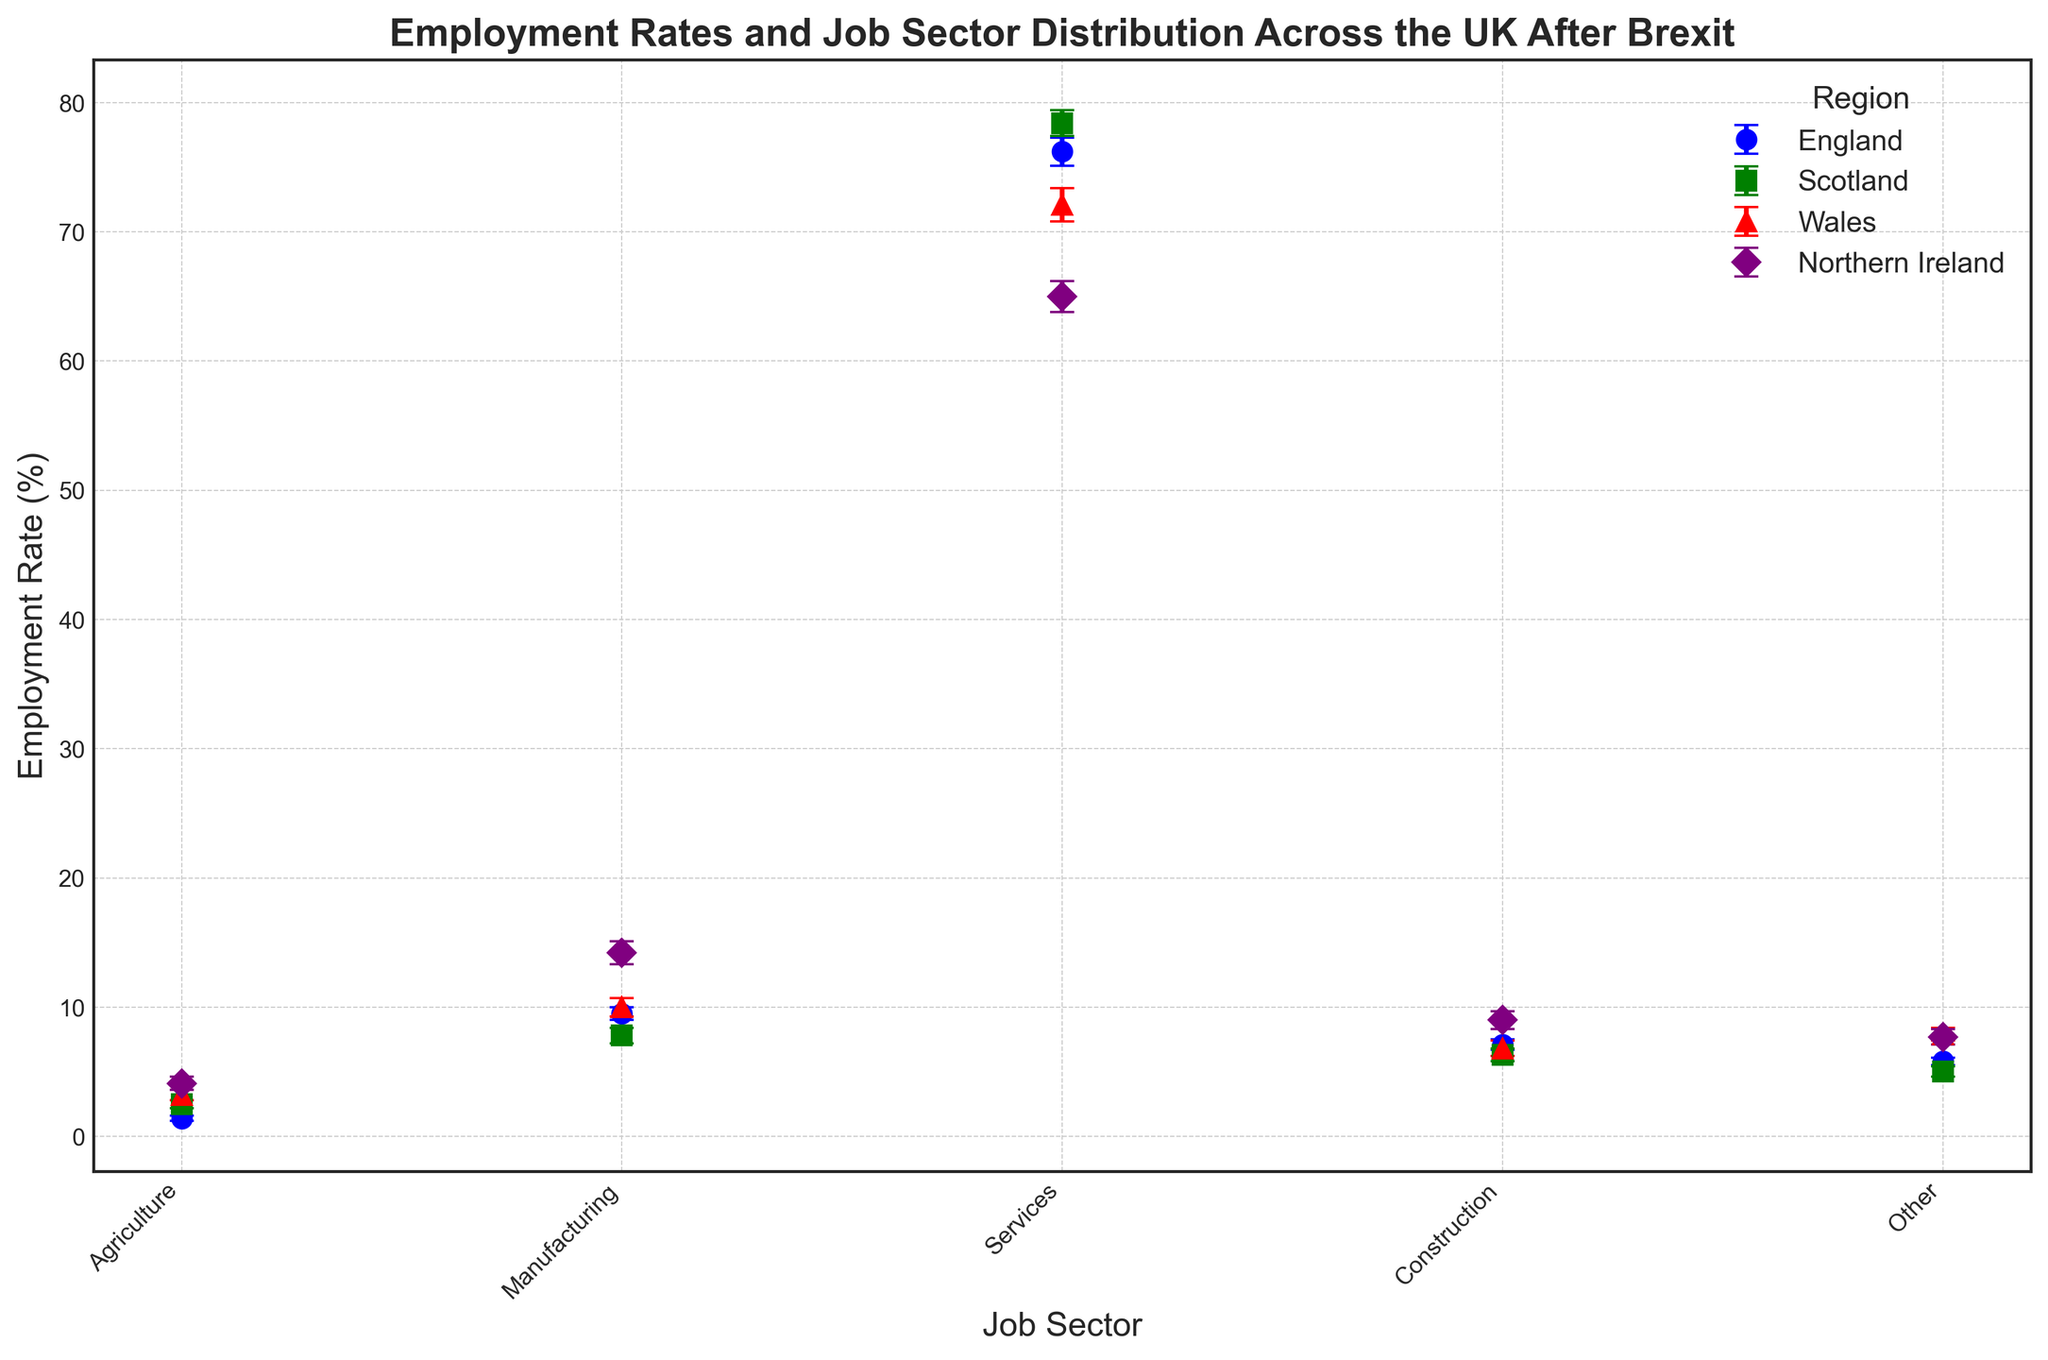How does the employment rate in agriculture differ between England and Wales? Find the employment rate for agriculture in both regions from the chart. England has an employment rate of 1.4% in agriculture, while Wales has an employment rate of 3.2%. Subtract the employment rate of England from that of Wales to find the difference. 3.2% - 1.4% = 1.8%
Answer: 1.8% Which region has the highest employment rate in services, and what is that rate? Identify the employment rate in services for each region from the chart. Scotland has the highest employment rate in services at 78.4%.
Answer: Scotland, 78.4% Compare the employment rates in manufacturing between Scotland and Northern Ireland. Which region has a higher rate, and by how much? Identify the manufacturing employment rates for Scotland and Northern Ireland from the chart. Scotland has a rate of 7.8%, while Northern Ireland has a rate of 14.2%. Subtract Scotland's rate from Northern Ireland's rate. 14.2% - 7.8% = 6.4%
Answer: Northern Ireland, 6.4% What is the average employment rate in construction across all regions, and which region has the nearest employment rate to this average? Add the employment rates in construction for all regions: 7.1% (England) + 6.3% (Scotland) + 6.8% (Wales) + 9.0% (Northern Ireland). Divide the sum by the number of regions (4). (7.1 + 6.3 + 6.8 + 9.0) / 4 = 29.2 / 4 = 7.3%. Wales has the nearest employment rate at 6.8%.
Answer: 7.3%, Wales Which region has the smallest standard error in the manufacturing sector, and what is that value? Identify the standard errors for the manufacturing sector in each region from the chart. England has the smallest standard error at 0.5%.
Answer: England, 0.5% How do the employment rates in the 'Other' sector for Wales and Northern Ireland compare visually on the chart? Look at the markers representing the 'Other' sector for both regions. Wales has a higher employment rate in the 'Other' sector (7.9%) compared to Northern Ireland (7.7%) as seen by the respective marker positions on the y-axis.
Answer: Wales is higher What is the total employment rate across all sectors for England, and how does it compare to Scotland? Add the employment rates across all sectors for England and Scotland. England: 1.4% (Agriculture) + 9.5% (Manufacturing) + 76.2% (Services) + 7.1% (Construction) + 5.8% (Other) = 100%. Scotland: 2.5% (Agriculture) + 7.8% (Manufacturing) + 78.4% (Services) + 6.3% (Construction) + 5.0% (Other) = 100%. Both regions have equal total employment rates across all sectors.
Answer: Equal 